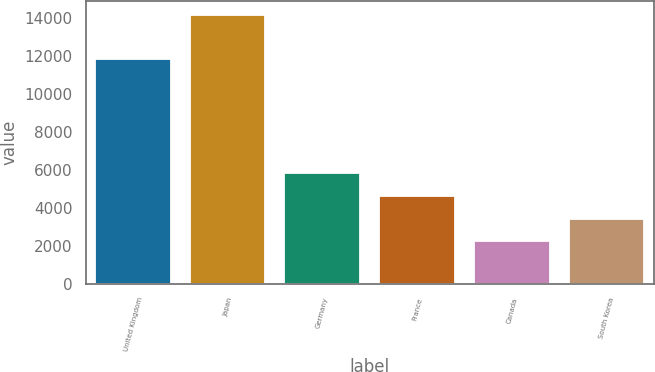Convert chart. <chart><loc_0><loc_0><loc_500><loc_500><bar_chart><fcel>United Kingdom<fcel>Japan<fcel>Germany<fcel>France<fcel>Canada<fcel>South Korea<nl><fcel>11807<fcel>14141<fcel>5803.3<fcel>4612.2<fcel>2230<fcel>3421.1<nl></chart> 